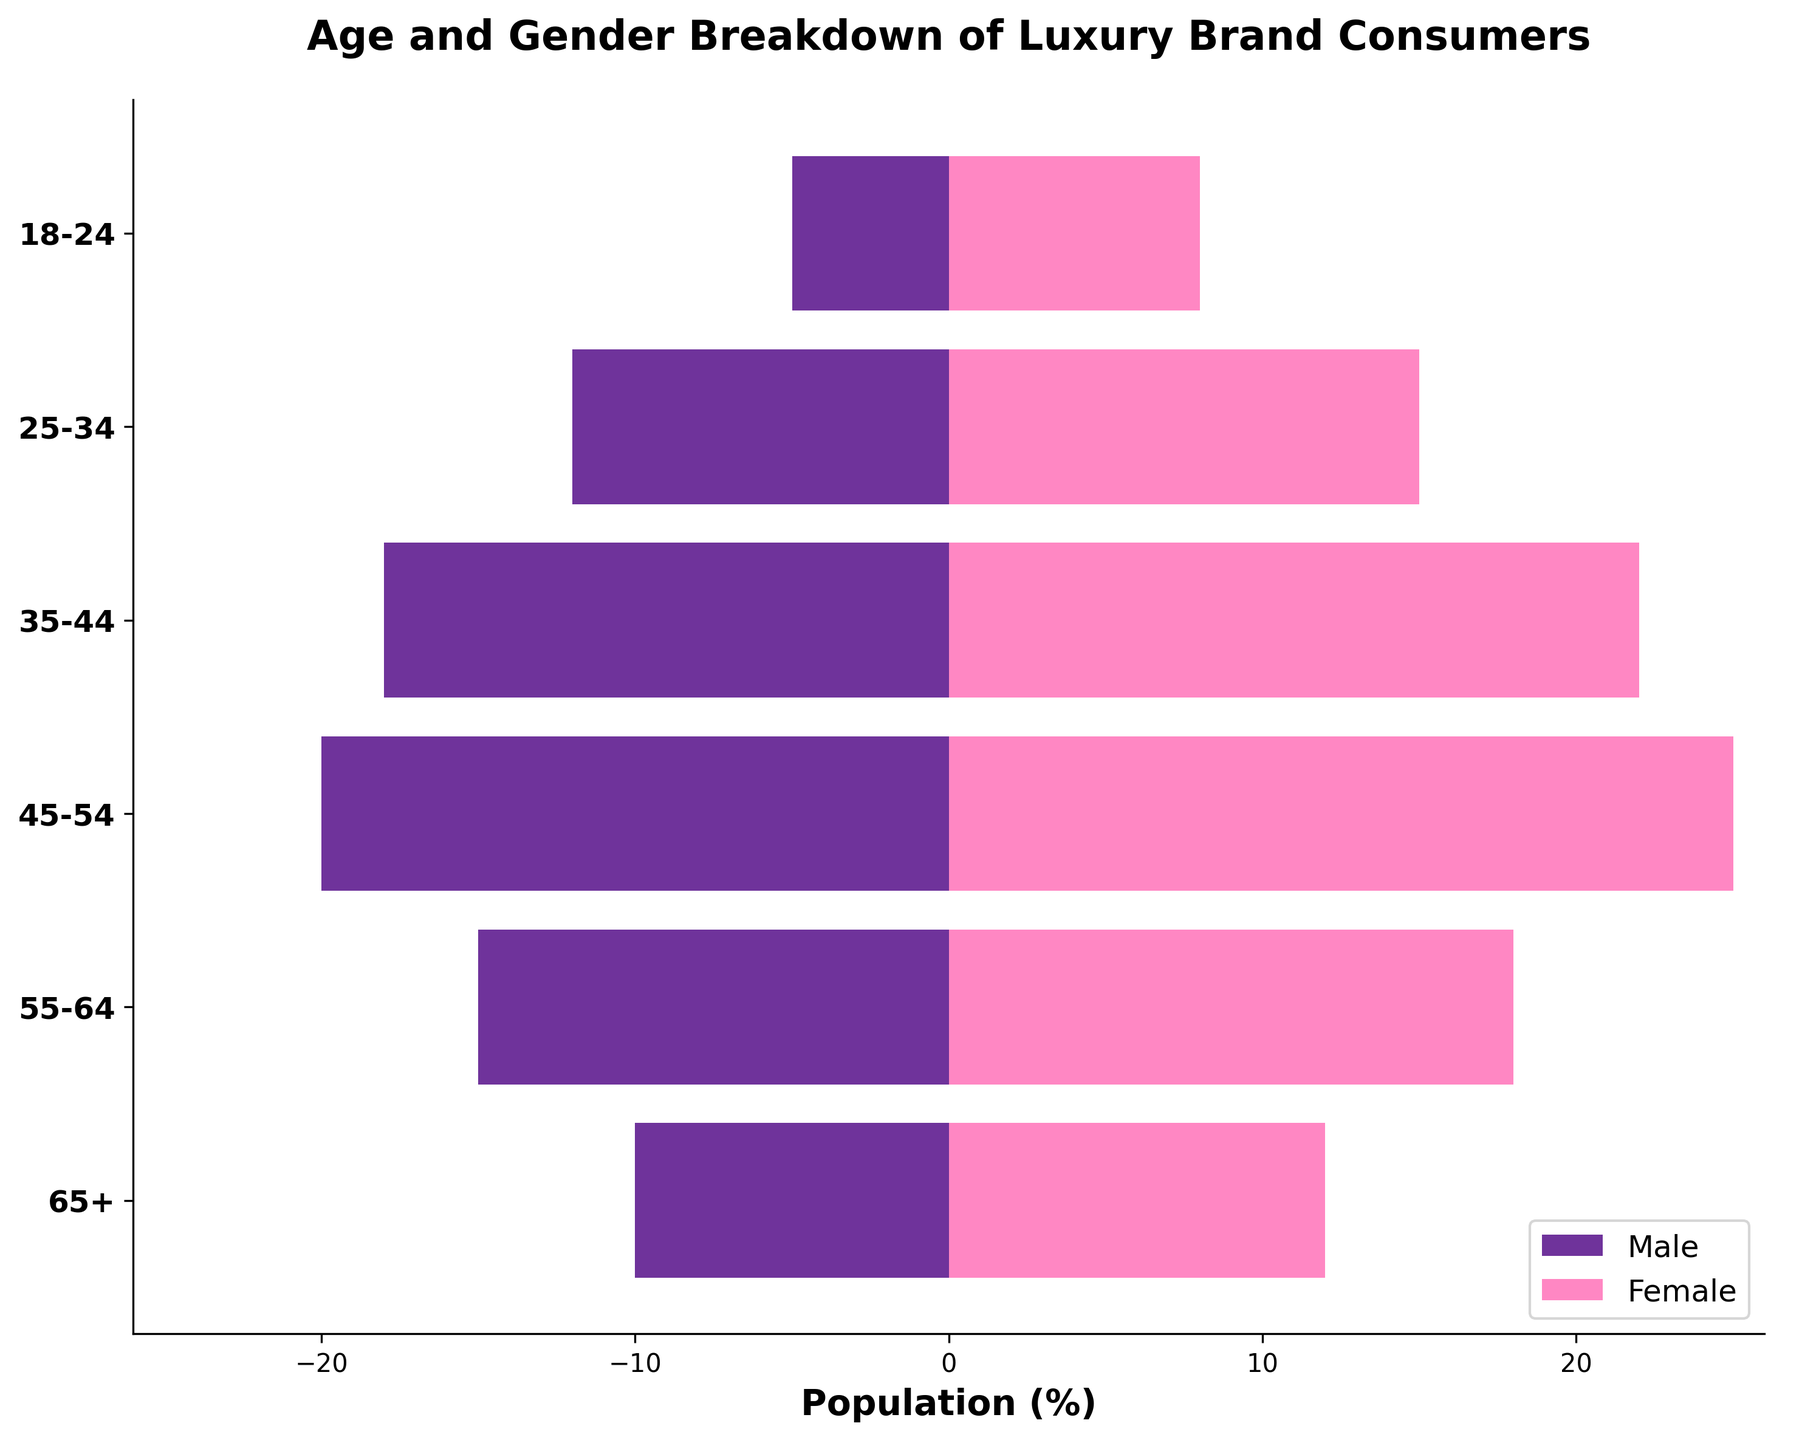What is the title of the figure? The title is typically found at the top of the figure and provides a brief description of what the figure represents. In this case, the title is "Age and Gender Breakdown of Luxury Brand Consumers".
Answer: Age and Gender Breakdown of Luxury Brand Consumers Which age group has the highest number of male consumers? To find this, look for the age group bar that extends the farthest to the left. This corresponds to the highest number of male consumers. The age group 45-54 has the longest bar to the left.
Answer: 45-54 Which age group has the highest number of female consumers? Look for the age group bar that extends the farthest to the right. This corresponds to the highest number of female consumers. The age group 45-54 has the longest bar to the right.
Answer: 45-54 How many age groups are represented in the figure? Each distinct horizontal bar represents a different age group. Count all the bars. There are six age groups represented.
Answer: 6 What is the total number of consumers in the 25-34 age group? Add the number of male consumers (12) and female consumers (15) in this age group. The sum is 12 + 15 = 27.
Answer: 27 How many more female consumers are there than male consumers in the 35-44 age group? Subtract the number of male consumers (18) from the number of female consumers (22) in this age group. The difference is 22 - 18 = 4.
Answer: 4 Which age group has the smallest gender disparity in luxury brand consumers? Calculate the difference between male and female consumers for each age group and identify the smallest difference. The age group 65+ has 10 male and 12 female consumers, making the disparity 2, which is the smallest.
Answer: 65+ What percentage of the total consumers in the 45-54 age group are male? First, calculate the total number of consumers in this age group by adding males (20) and females (25) to get 45. Then, divide the number of male consumers by the total and multiply by 100: (20 / 45) * 100 ≈ 44.44%.
Answer: 44.44% Which gender has a higher representation in the 55-64 age group? Compare the number of male consumers (15) to female consumers (18) in the 55-64 age group. There are more female consumers.
Answer: Female What is the range of the number of consumers in the male category across all age groups? Identify the maximum and minimum values in the male category. The maximum number of male consumers is 20 (45-54 age group), and the minimum is 5 (18-24 age group). The range is 20 - 5 = 15.
Answer: 15 